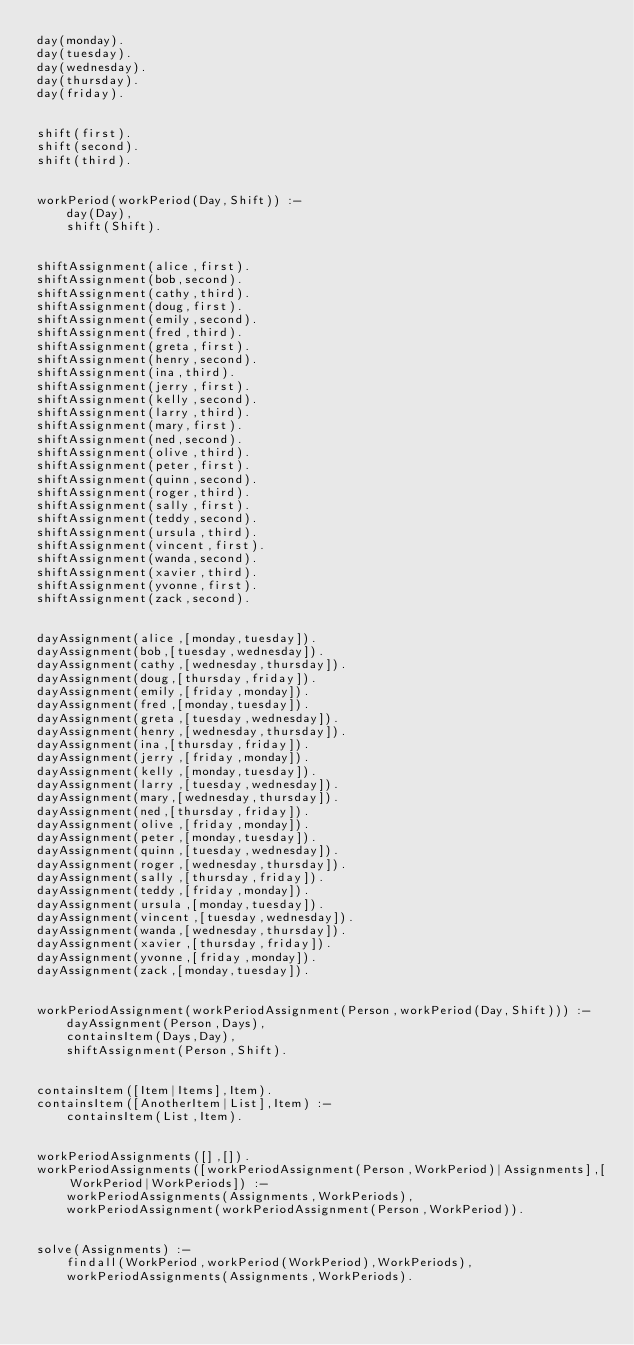Convert code to text. <code><loc_0><loc_0><loc_500><loc_500><_Prolog_>day(monday).
day(tuesday).
day(wednesday).
day(thursday).
day(friday).


shift(first).
shift(second).
shift(third).


workPeriod(workPeriod(Day,Shift)) :-
    day(Day),
    shift(Shift).


shiftAssignment(alice,first).
shiftAssignment(bob,second).
shiftAssignment(cathy,third).
shiftAssignment(doug,first).
shiftAssignment(emily,second).
shiftAssignment(fred,third).
shiftAssignment(greta,first).
shiftAssignment(henry,second).
shiftAssignment(ina,third).
shiftAssignment(jerry,first).
shiftAssignment(kelly,second).
shiftAssignment(larry,third).
shiftAssignment(mary,first).
shiftAssignment(ned,second).
shiftAssignment(olive,third).
shiftAssignment(peter,first).
shiftAssignment(quinn,second).
shiftAssignment(roger,third).
shiftAssignment(sally,first).
shiftAssignment(teddy,second).
shiftAssignment(ursula,third).
shiftAssignment(vincent,first).
shiftAssignment(wanda,second).
shiftAssignment(xavier,third).
shiftAssignment(yvonne,first).
shiftAssignment(zack,second).


dayAssignment(alice,[monday,tuesday]).
dayAssignment(bob,[tuesday,wednesday]).
dayAssignment(cathy,[wednesday,thursday]).
dayAssignment(doug,[thursday,friday]).
dayAssignment(emily,[friday,monday]).
dayAssignment(fred,[monday,tuesday]).
dayAssignment(greta,[tuesday,wednesday]).
dayAssignment(henry,[wednesday,thursday]).
dayAssignment(ina,[thursday,friday]).
dayAssignment(jerry,[friday,monday]).
dayAssignment(kelly,[monday,tuesday]).
dayAssignment(larry,[tuesday,wednesday]).
dayAssignment(mary,[wednesday,thursday]).
dayAssignment(ned,[thursday,friday]).
dayAssignment(olive,[friday,monday]).
dayAssignment(peter,[monday,tuesday]).
dayAssignment(quinn,[tuesday,wednesday]).
dayAssignment(roger,[wednesday,thursday]).
dayAssignment(sally,[thursday,friday]).
dayAssignment(teddy,[friday,monday]).
dayAssignment(ursula,[monday,tuesday]).
dayAssignment(vincent,[tuesday,wednesday]).
dayAssignment(wanda,[wednesday,thursday]).
dayAssignment(xavier,[thursday,friday]).
dayAssignment(yvonne,[friday,monday]).
dayAssignment(zack,[monday,tuesday]).


workPeriodAssignment(workPeriodAssignment(Person,workPeriod(Day,Shift))) :-
    dayAssignment(Person,Days),
    containsItem(Days,Day),
    shiftAssignment(Person,Shift).


containsItem([Item|Items],Item).
containsItem([AnotherItem|List],Item) :-
    containsItem(List,Item).


workPeriodAssignments([],[]).
workPeriodAssignments([workPeriodAssignment(Person,WorkPeriod)|Assignments],[WorkPeriod|WorkPeriods]) :-
    workPeriodAssignments(Assignments,WorkPeriods),
    workPeriodAssignment(workPeriodAssignment(Person,WorkPeriod)).


solve(Assignments) :-
    findall(WorkPeriod,workPeriod(WorkPeriod),WorkPeriods),
    workPeriodAssignments(Assignments,WorkPeriods).
</code> 